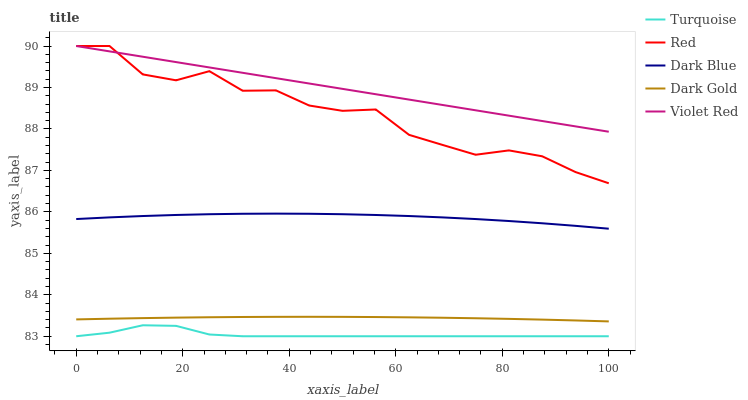Does Turquoise have the minimum area under the curve?
Answer yes or no. Yes. Does Violet Red have the maximum area under the curve?
Answer yes or no. Yes. Does Violet Red have the minimum area under the curve?
Answer yes or no. No. Does Turquoise have the maximum area under the curve?
Answer yes or no. No. Is Violet Red the smoothest?
Answer yes or no. Yes. Is Red the roughest?
Answer yes or no. Yes. Is Turquoise the smoothest?
Answer yes or no. No. Is Turquoise the roughest?
Answer yes or no. No. Does Turquoise have the lowest value?
Answer yes or no. Yes. Does Violet Red have the lowest value?
Answer yes or no. No. Does Red have the highest value?
Answer yes or no. Yes. Does Turquoise have the highest value?
Answer yes or no. No. Is Dark Gold less than Violet Red?
Answer yes or no. Yes. Is Dark Blue greater than Turquoise?
Answer yes or no. Yes. Does Violet Red intersect Red?
Answer yes or no. Yes. Is Violet Red less than Red?
Answer yes or no. No. Is Violet Red greater than Red?
Answer yes or no. No. Does Dark Gold intersect Violet Red?
Answer yes or no. No. 